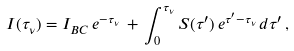<formula> <loc_0><loc_0><loc_500><loc_500>I ( \tau _ { \nu } ) = I _ { B C } \, e ^ { - \tau _ { \nu } } \, + \, \int _ { 0 } ^ { \tau _ { \nu } } S ( \tau ^ { \prime } ) \, e ^ { \tau ^ { \prime } - \tau _ { \nu } } \, d \tau ^ { \prime } \, ,</formula> 